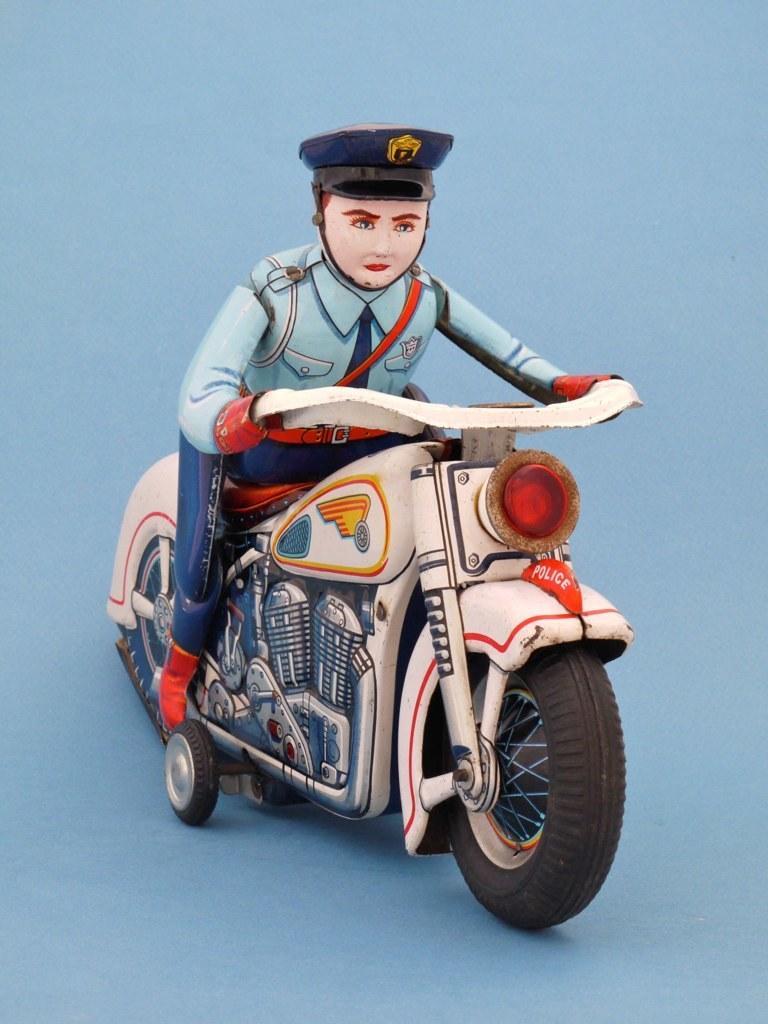How would you summarize this image in a sentence or two? As we can see in the image there is a man sitting on motorcycle. 